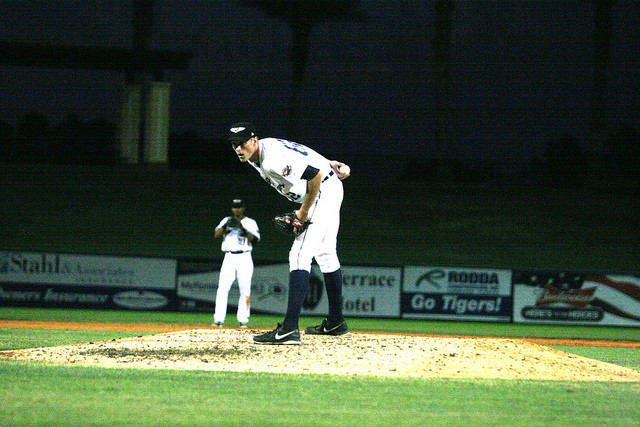Read all the text in this image. Go RODOA errace 